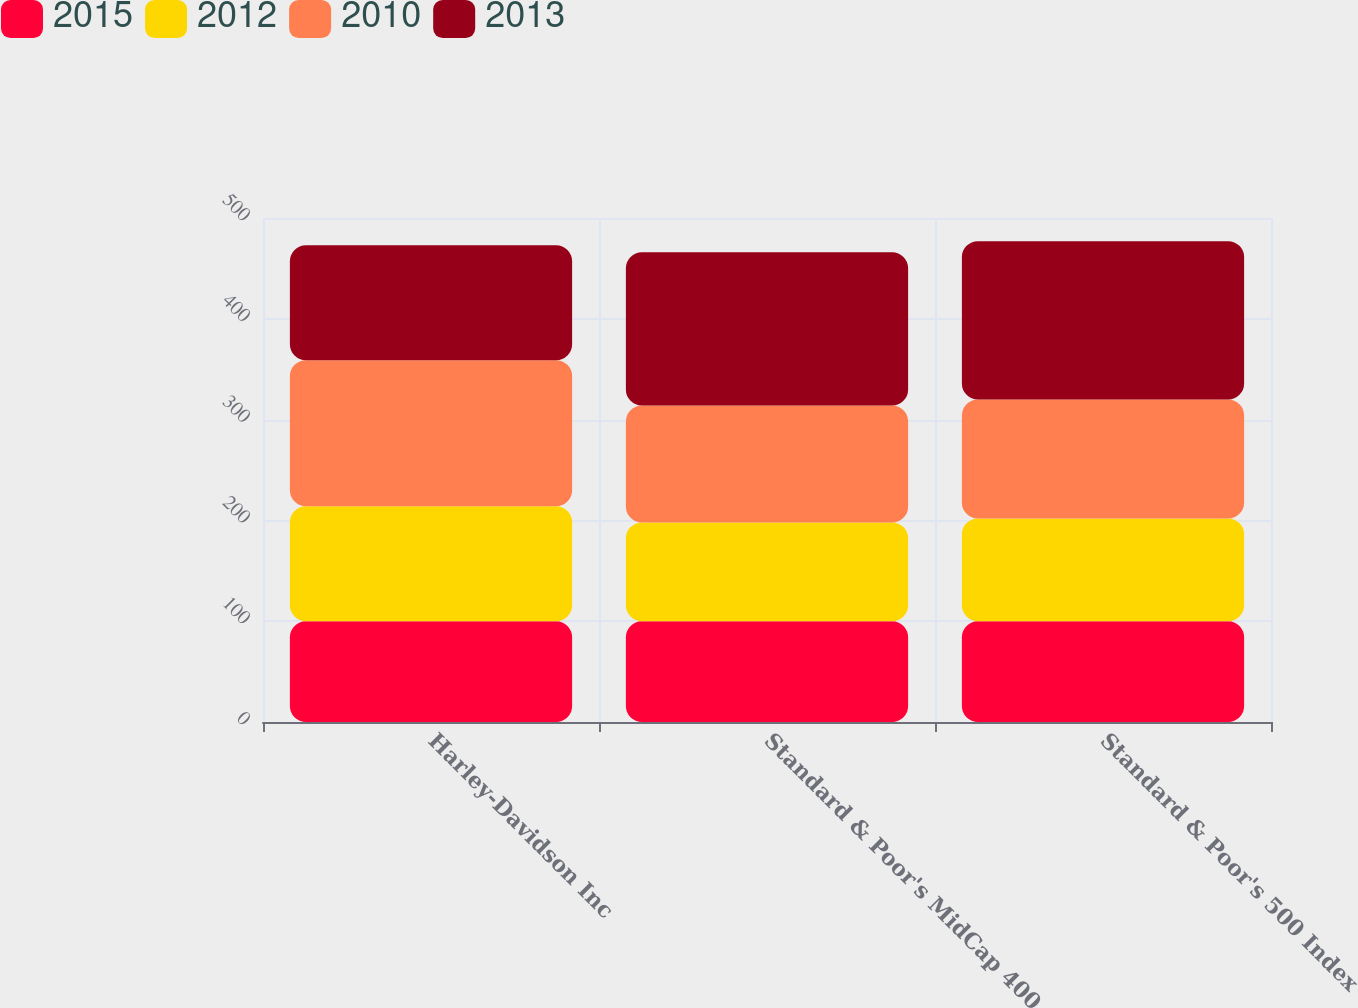Convert chart. <chart><loc_0><loc_0><loc_500><loc_500><stacked_bar_chart><ecel><fcel>Harley-Davidson Inc<fcel>Standard & Poor's MidCap 400<fcel>Standard & Poor's 500 Index<nl><fcel>2015<fcel>100<fcel>100<fcel>100<nl><fcel>2012<fcel>114<fcel>98<fcel>102<nl><fcel>2010<fcel>145<fcel>116<fcel>118<nl><fcel>2013<fcel>114<fcel>152<fcel>157<nl></chart> 